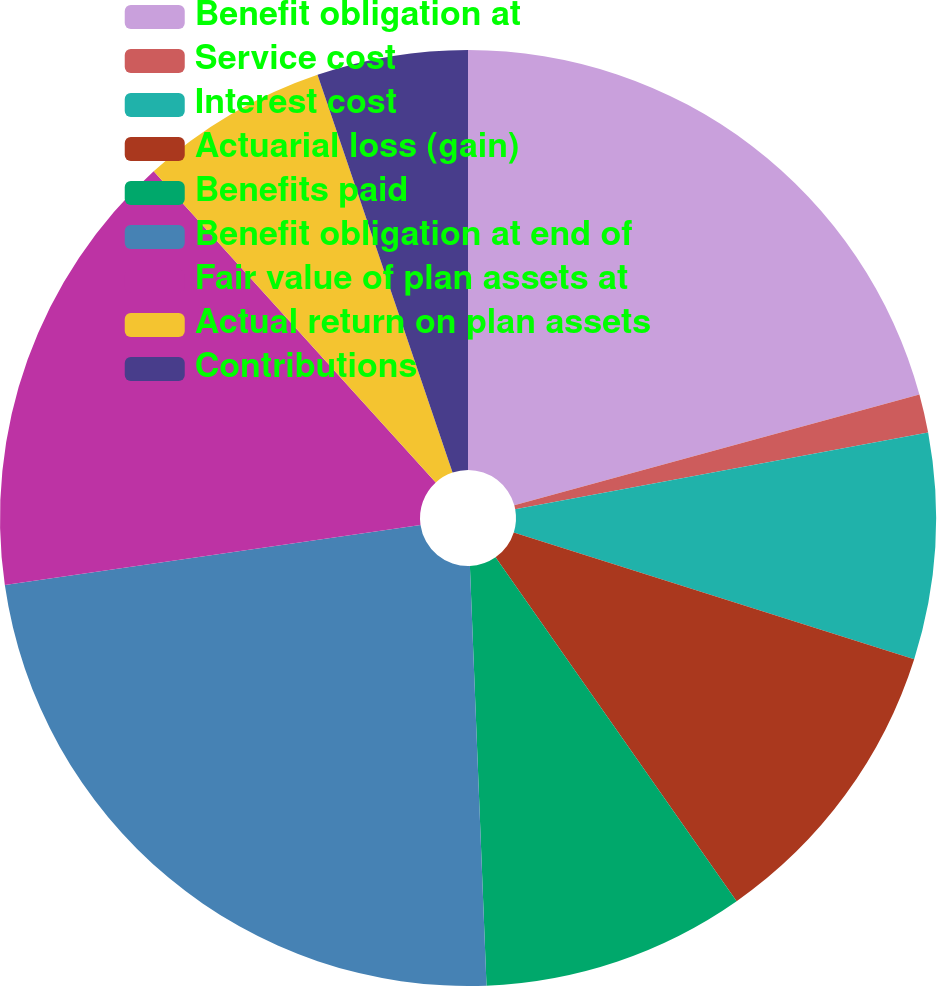Convert chart to OTSL. <chart><loc_0><loc_0><loc_500><loc_500><pie_chart><fcel>Benefit obligation at<fcel>Service cost<fcel>Interest cost<fcel>Actuarial loss (gain)<fcel>Benefits paid<fcel>Benefit obligation at end of<fcel>Fair value of plan assets at<fcel>Actual return on plan assets<fcel>Contributions<nl><fcel>20.75%<fcel>1.33%<fcel>7.8%<fcel>10.39%<fcel>9.1%<fcel>23.34%<fcel>15.57%<fcel>6.51%<fcel>5.21%<nl></chart> 